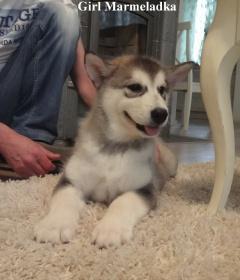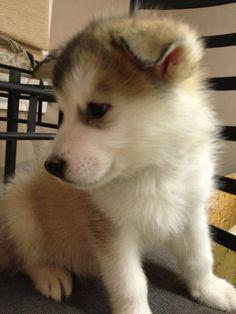The first image is the image on the left, the second image is the image on the right. Analyze the images presented: Is the assertion "The left image features a puppy sitting upright in profile, and the right image features a grey-and-white husky facing forward." valid? Answer yes or no. No. The first image is the image on the left, the second image is the image on the right. Considering the images on both sides, is "Exactly one dog is sitting." valid? Answer yes or no. Yes. 